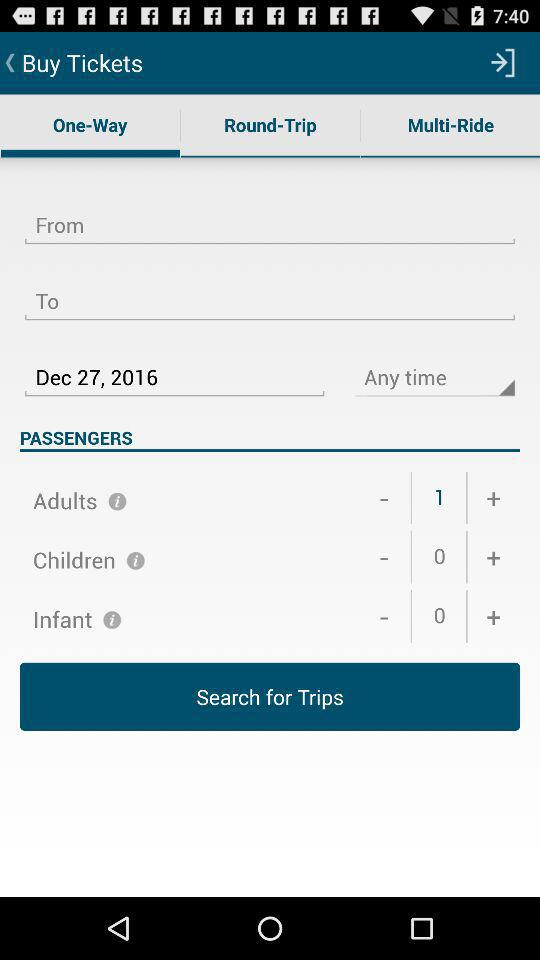How many more adults than children are there?
Answer the question using a single word or phrase. 1 